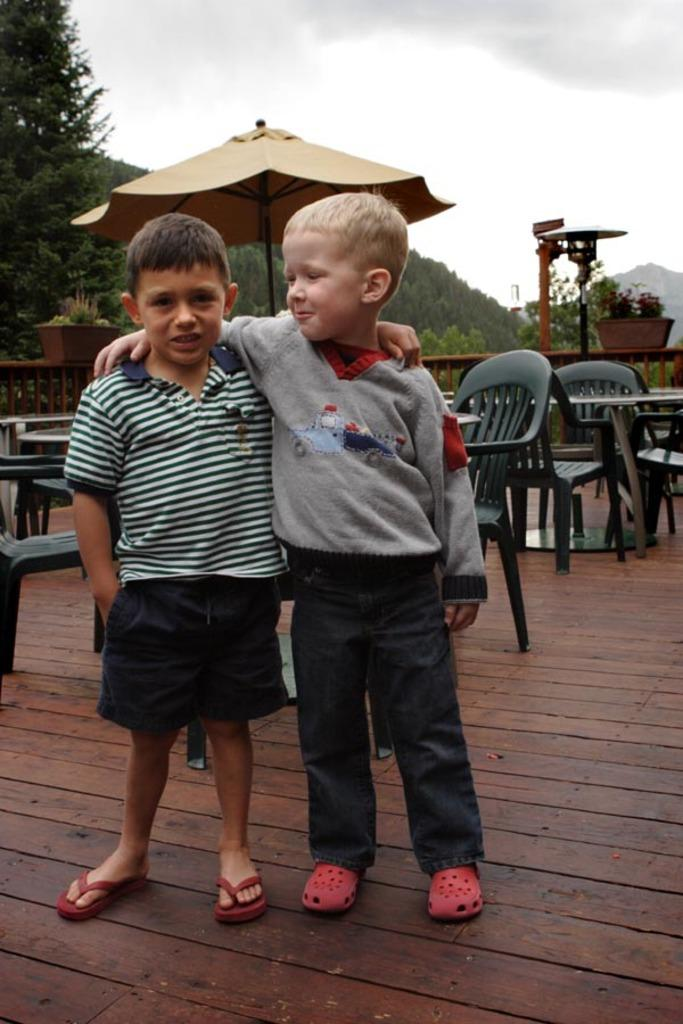How many kids are in the image? There are two kids in the image. What are the kids doing in the image? The kids are standing on the floor. What can be seen in the background of the image? There are chairs and trees in the background of the image. What is the father doing in the image? There is no father present in the image. How quiet is the environment in the image? The provided facts do not give any information about the noise level or environment's quietness. 